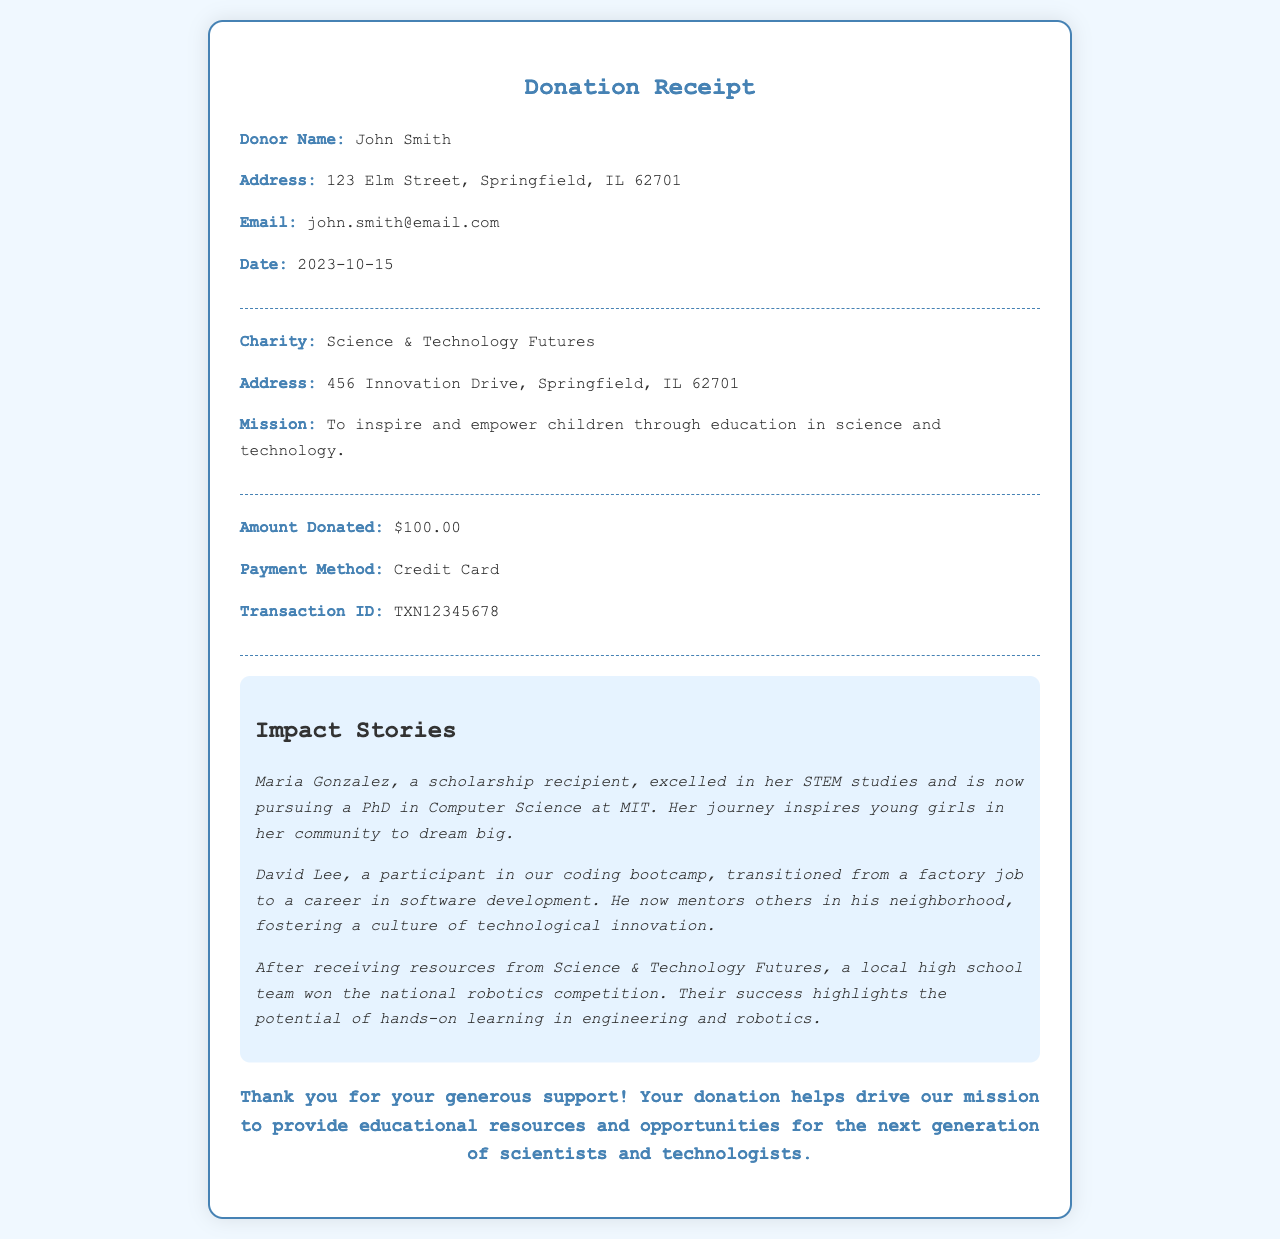What is the donor's name? The donor's name is specified at the top of the receipt under 'Donor Name.'
Answer: John Smith What is the donation amount? The donation amount is clearly listed in the donation section of the receipt.
Answer: $100.00 What is the mission of the charity? The mission of the charity can be found in the corresponding section of the receipt.
Answer: To inspire and empower children through education in science and technology Who is Maria Gonzalez? Maria Gonzalez is mentioned in the impact stories section as a scholarship recipient who pursued a PhD.
Answer: A scholarship recipient On what date was the donation made? The date of the donation is stated in the donor information section of the receipt.
Answer: 2023-10-15 What transformation did David Lee undergo? David Lee's transformation is highlighted in the impact stories, focusing on his career change.
Answer: From factory job to software development What type of resources did the local high school team receive? The type of resources received by the high school team is detailed within the impact stories section of the document.
Answer: Resources from Science & Technology Futures What is the transaction ID? The transaction ID for the donation is provided in the donation details section.
Answer: TXN12345678 